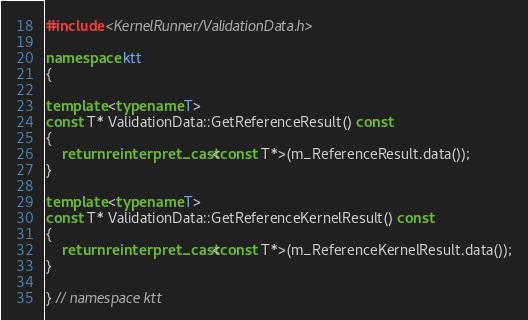Convert code to text. <code><loc_0><loc_0><loc_500><loc_500><_C++_>#include <KernelRunner/ValidationData.h>

namespace ktt
{

template <typename T>
const T* ValidationData::GetReferenceResult() const
{
    return reinterpret_cast<const T*>(m_ReferenceResult.data());
}

template <typename T>
const T* ValidationData::GetReferenceKernelResult() const
{
    return reinterpret_cast<const T*>(m_ReferenceKernelResult.data());
}

} // namespace ktt
</code> 